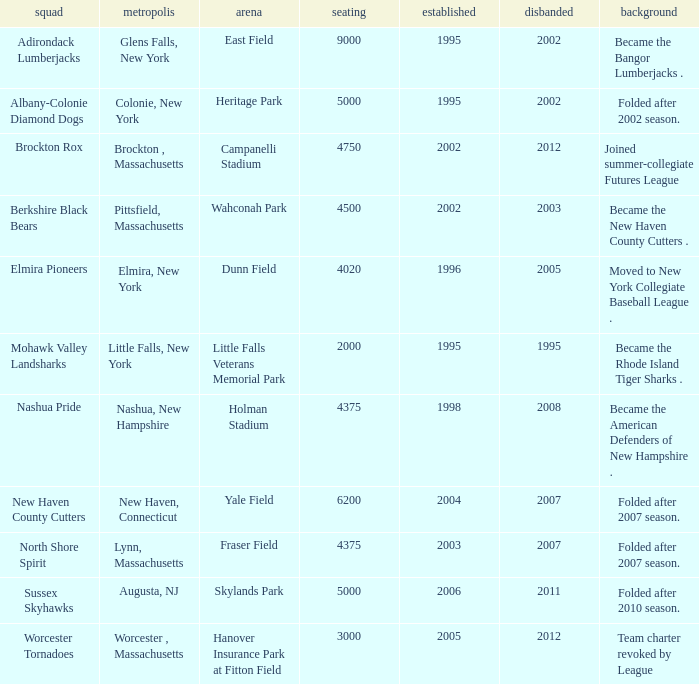What is the maximum folded value of the team whose stadium is Fraser Field? 2007.0. 